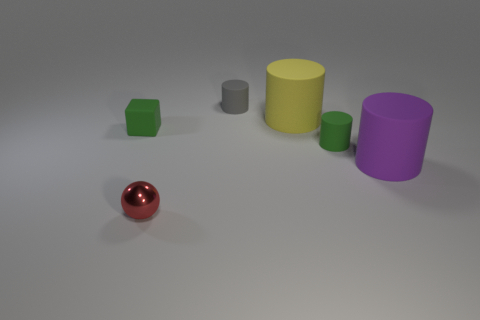Is there anything else that is the same material as the tiny red sphere?
Offer a terse response. No. What is the color of the other large rubber thing that is the same shape as the purple matte thing?
Your answer should be compact. Yellow. Are there any small green cubes behind the big matte cylinder to the left of the big purple object?
Make the answer very short. No. Does the green object right of the tiny gray rubber thing have the same shape as the small red object?
Your answer should be compact. No. What is the shape of the purple matte thing?
Keep it short and to the point. Cylinder. How many yellow things have the same material as the tiny green cube?
Your answer should be very brief. 1. Does the tiny matte cube have the same color as the matte cylinder on the left side of the large yellow rubber thing?
Offer a terse response. No. What number of green matte things are there?
Provide a short and direct response. 2. Is there a small thing of the same color as the metallic ball?
Make the answer very short. No. The large thing that is behind the big thing that is to the right of the small green matte thing that is right of the tiny gray rubber thing is what color?
Your answer should be very brief. Yellow. 